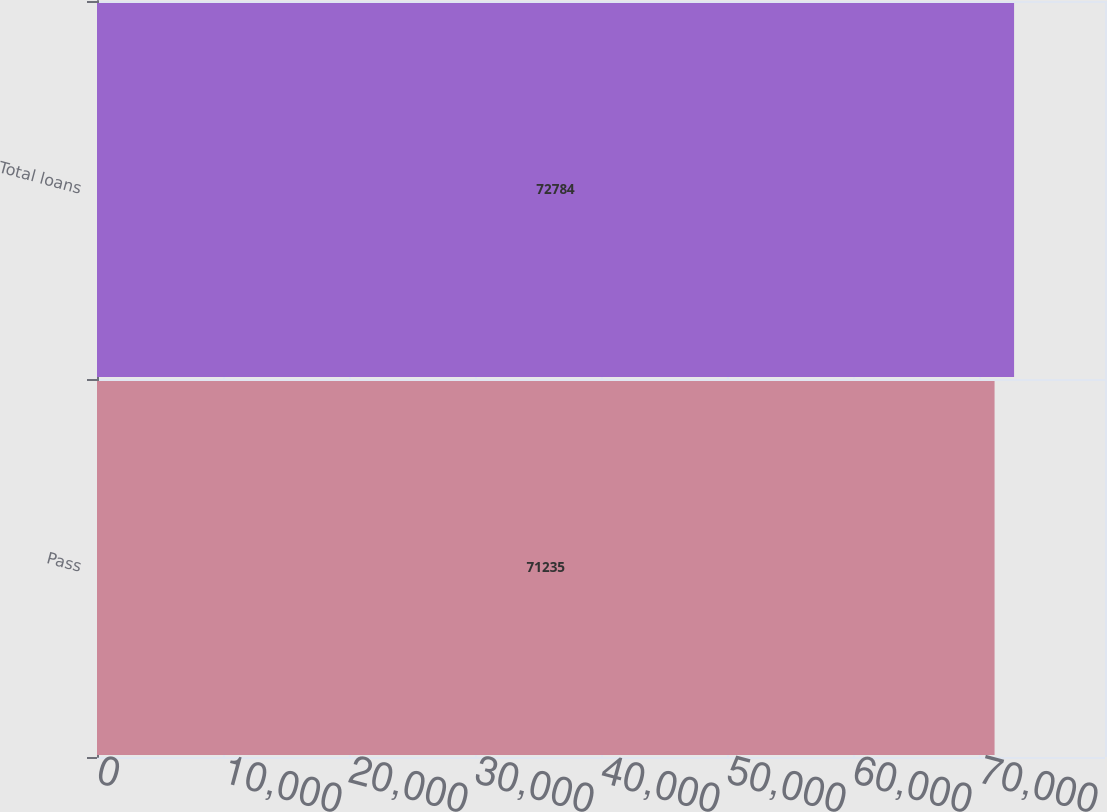Convert chart to OTSL. <chart><loc_0><loc_0><loc_500><loc_500><bar_chart><fcel>Pass<fcel>Total loans<nl><fcel>71235<fcel>72784<nl></chart> 